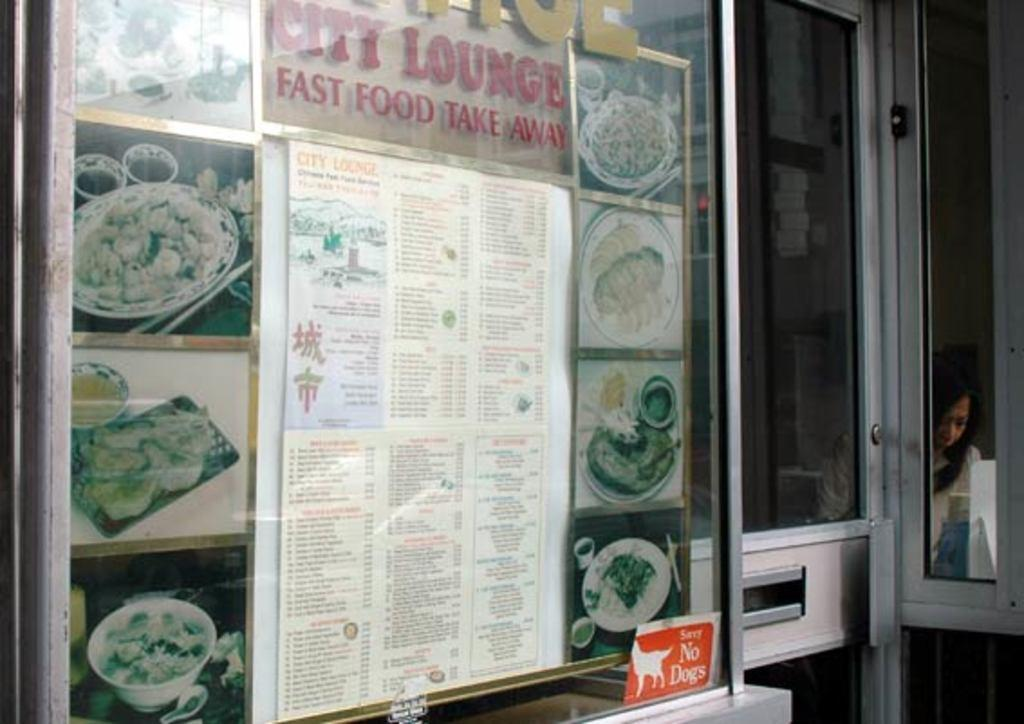<image>
Share a concise interpretation of the image provided. City lounge fast food take away menu showing in restaurant 